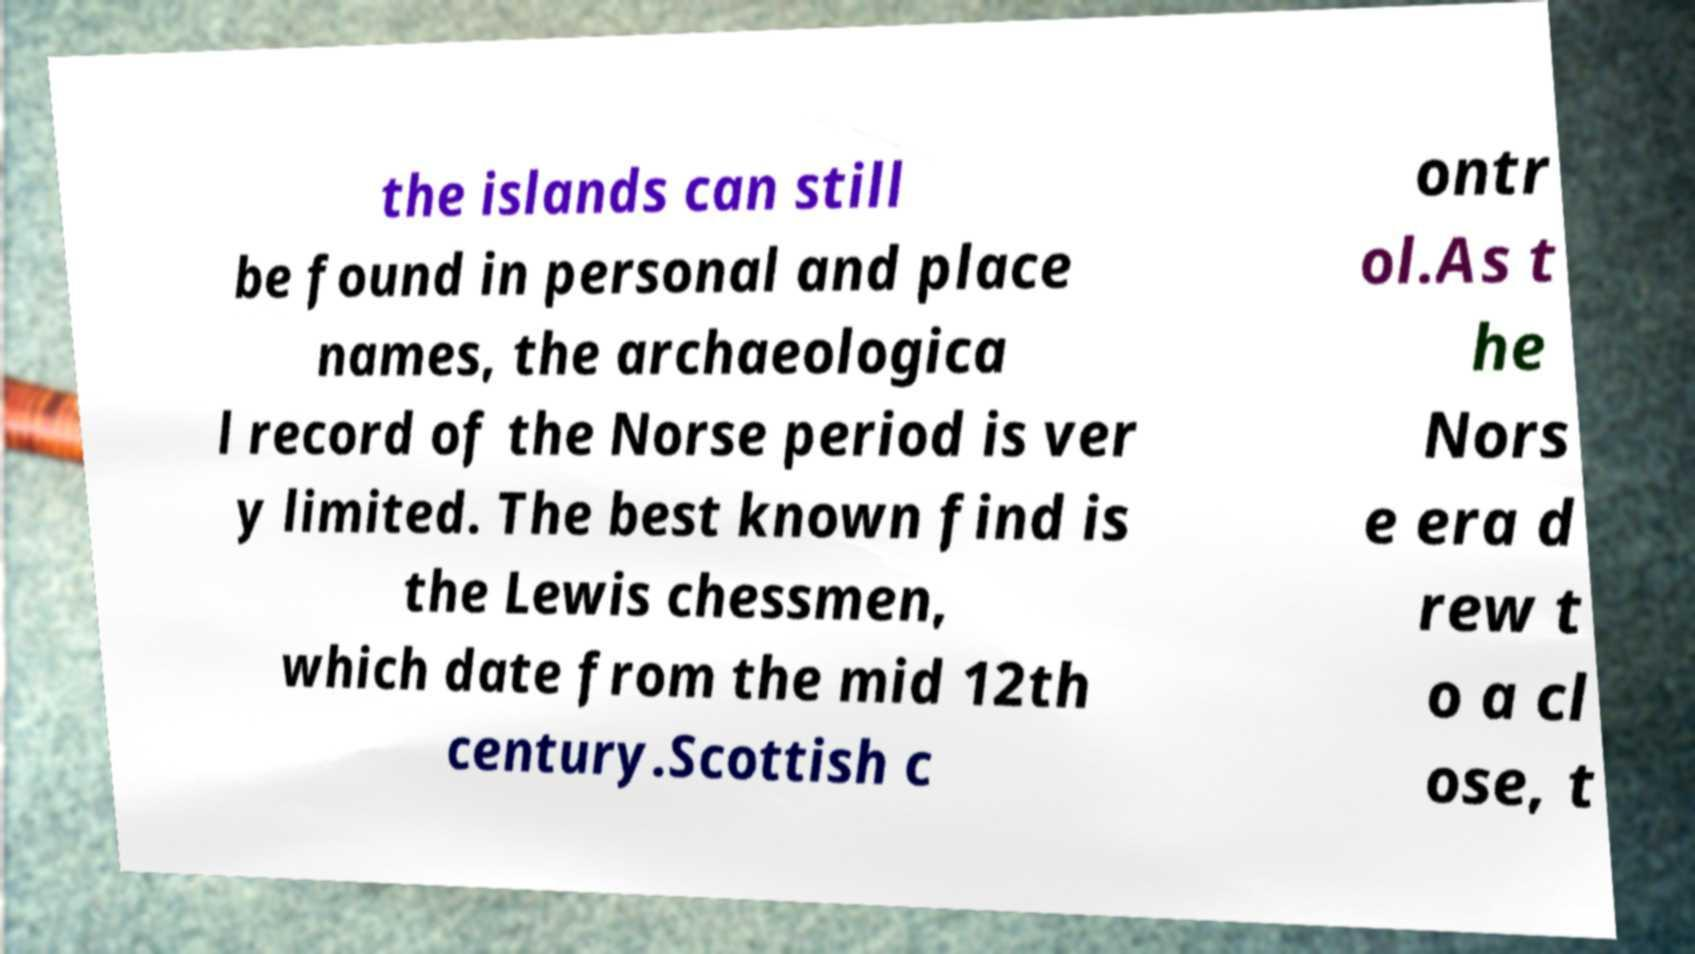Please identify and transcribe the text found in this image. the islands can still be found in personal and place names, the archaeologica l record of the Norse period is ver y limited. The best known find is the Lewis chessmen, which date from the mid 12th century.Scottish c ontr ol.As t he Nors e era d rew t o a cl ose, t 